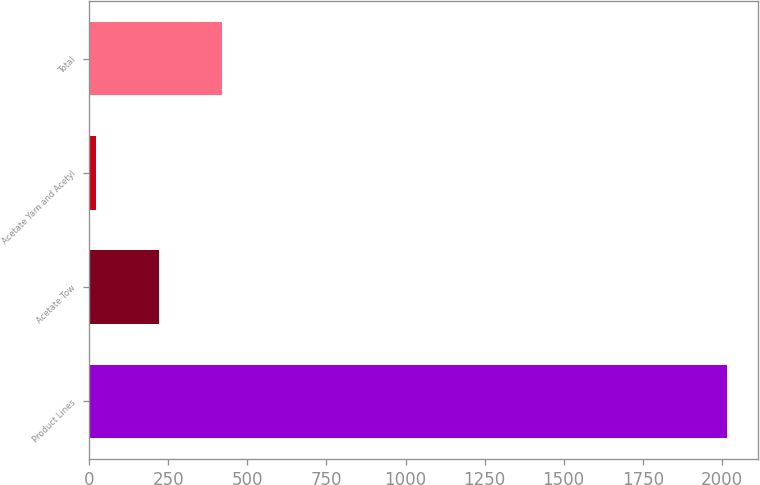<chart> <loc_0><loc_0><loc_500><loc_500><bar_chart><fcel>Product Lines<fcel>Acetate Tow<fcel>Acetate Yarn and Acetyl<fcel>Total<nl><fcel>2015<fcel>221.3<fcel>22<fcel>420.6<nl></chart> 